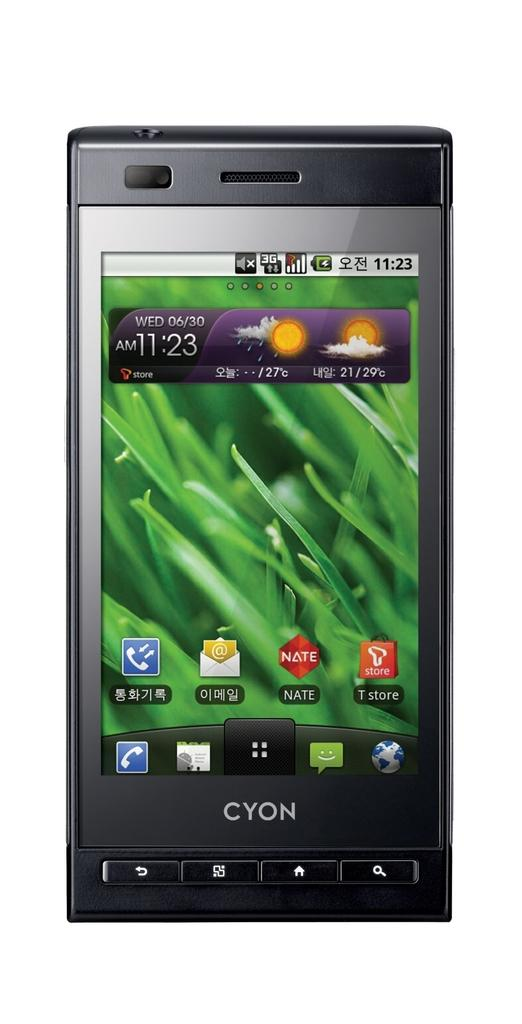<image>
Render a clear and concise summary of the photo. A CYON cell phone is showing the time of 11:23 AM. 